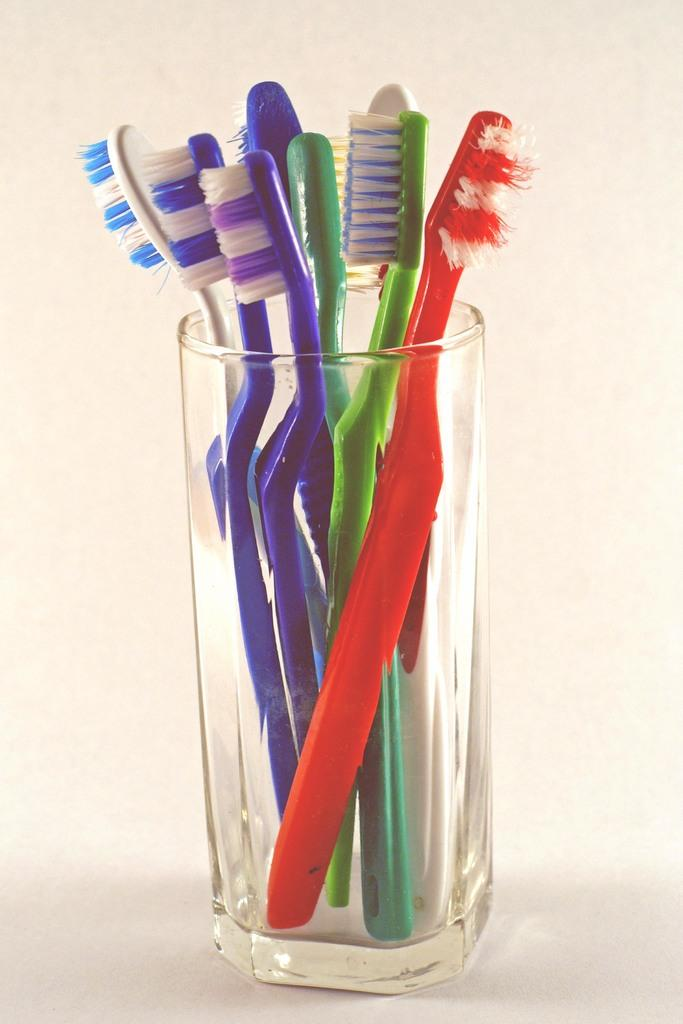What objects are in the image? There are colorful brushes in the image. How are the brushes stored or displayed? The brushes are in a glass. What is the color of the background in the image? The background of the image is white. What type of voice can be heard coming from the brushes in the image? There is no voice present in the image, as the image features colorful brushes in a glass. What wish can be granted by the brushes in the image? There is no wish-granting ability associated with the brushes in the image. 